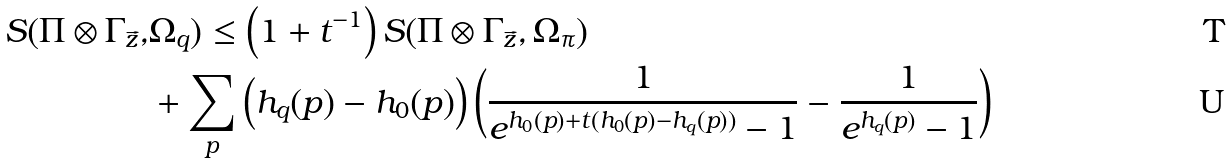Convert formula to latex. <formula><loc_0><loc_0><loc_500><loc_500>S ( \Pi \otimes \Gamma _ { \vec { z } } , & \Omega _ { q } ) \leq \left ( 1 + t ^ { - 1 } \right ) S ( \Pi \otimes \Gamma _ { \vec { z } } , \Omega _ { \pi } ) \\ & + \sum _ { p } \left ( h _ { q } ( p ) - h _ { 0 } ( p ) \right ) \left ( \frac { 1 } { e ^ { h _ { 0 } ( p ) + t ( h _ { 0 } ( p ) - h _ { q } ( p ) ) } - 1 } - \frac { 1 } { e ^ { h _ { q } ( p ) } - 1 } \right )</formula> 